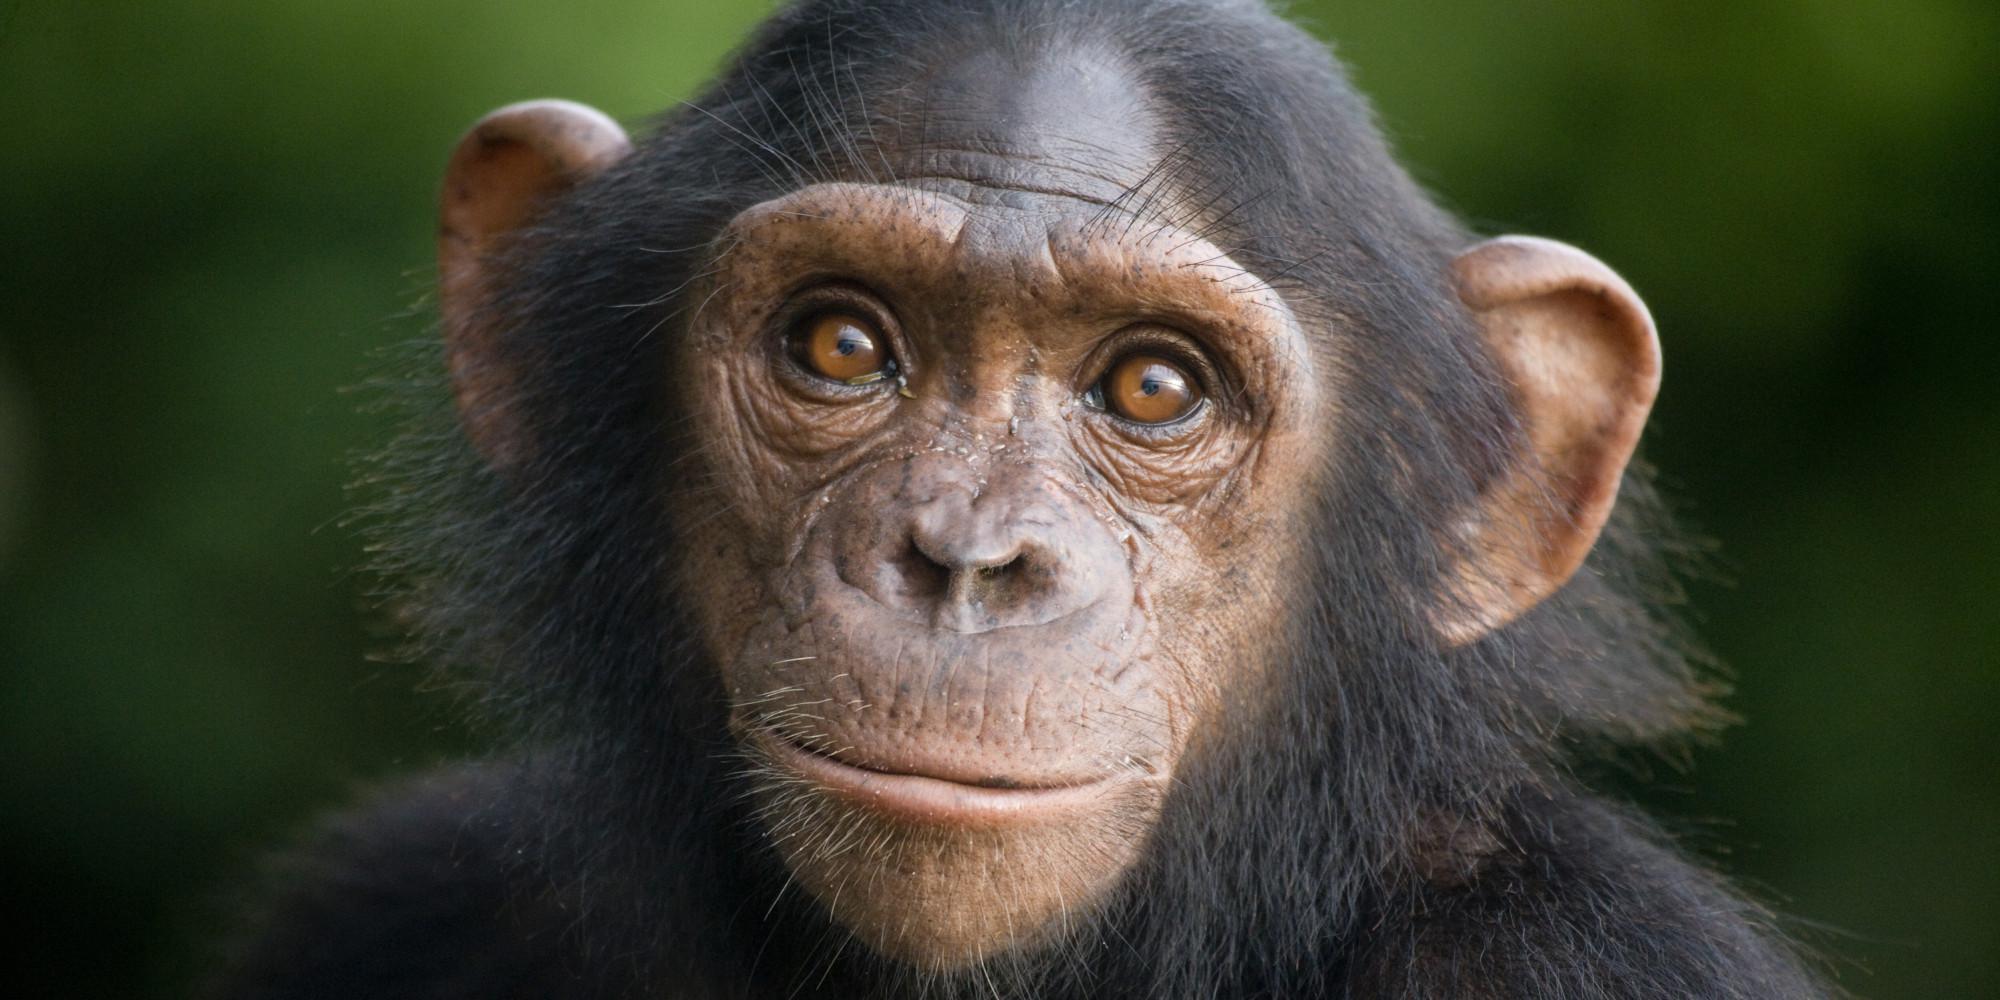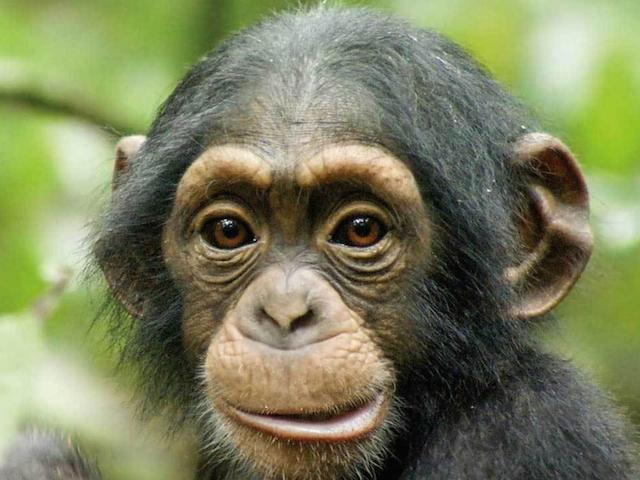The first image is the image on the left, the second image is the image on the right. Assess this claim about the two images: "The monkey in one of the images is opening its mouth to reveal teeth.". Correct or not? Answer yes or no. No. The first image is the image on the left, the second image is the image on the right. Analyze the images presented: Is the assertion "Each image shows one forward-facing young chimp with a light-colored face and ears that protrude." valid? Answer yes or no. Yes. 